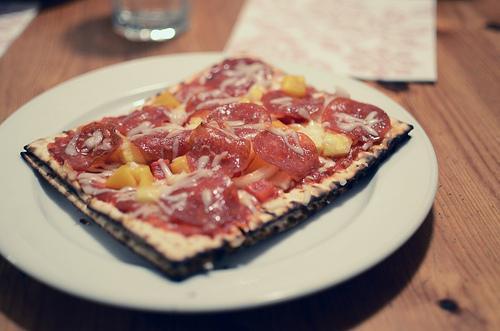How many plates of food?
Give a very brief answer. 1. 